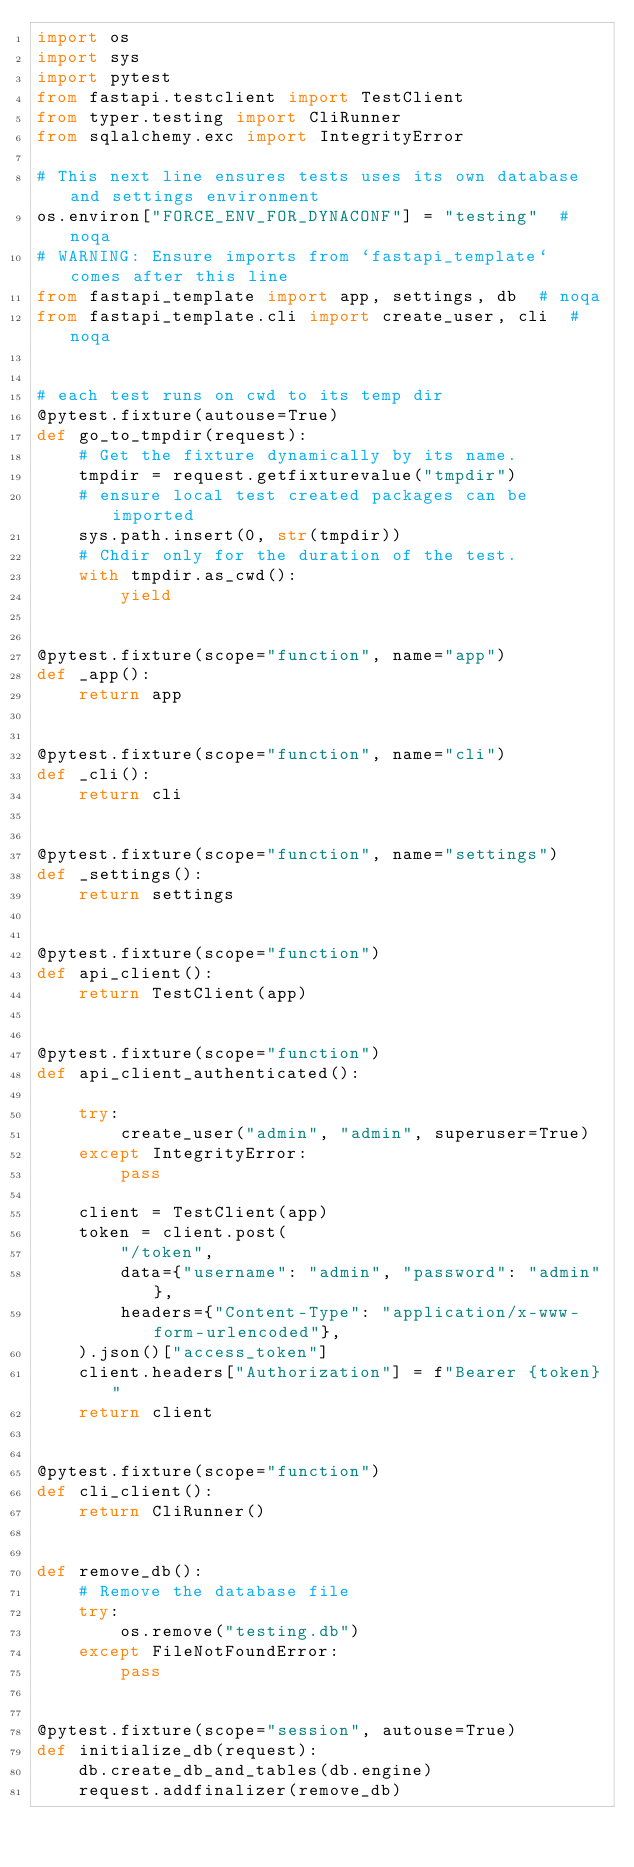Convert code to text. <code><loc_0><loc_0><loc_500><loc_500><_Python_>import os
import sys
import pytest
from fastapi.testclient import TestClient
from typer.testing import CliRunner
from sqlalchemy.exc import IntegrityError

# This next line ensures tests uses its own database and settings environment
os.environ["FORCE_ENV_FOR_DYNACONF"] = "testing"  # noqa
# WARNING: Ensure imports from `fastapi_template` comes after this line
from fastapi_template import app, settings, db  # noqa
from fastapi_template.cli import create_user, cli  # noqa


# each test runs on cwd to its temp dir
@pytest.fixture(autouse=True)
def go_to_tmpdir(request):
    # Get the fixture dynamically by its name.
    tmpdir = request.getfixturevalue("tmpdir")
    # ensure local test created packages can be imported
    sys.path.insert(0, str(tmpdir))
    # Chdir only for the duration of the test.
    with tmpdir.as_cwd():
        yield


@pytest.fixture(scope="function", name="app")
def _app():
    return app


@pytest.fixture(scope="function", name="cli")
def _cli():
    return cli


@pytest.fixture(scope="function", name="settings")
def _settings():
    return settings


@pytest.fixture(scope="function")
def api_client():
    return TestClient(app)


@pytest.fixture(scope="function")
def api_client_authenticated():

    try:
        create_user("admin", "admin", superuser=True)
    except IntegrityError:
        pass

    client = TestClient(app)
    token = client.post(
        "/token",
        data={"username": "admin", "password": "admin"},
        headers={"Content-Type": "application/x-www-form-urlencoded"},
    ).json()["access_token"]
    client.headers["Authorization"] = f"Bearer {token}"
    return client


@pytest.fixture(scope="function")
def cli_client():
    return CliRunner()


def remove_db():
    # Remove the database file
    try:
        os.remove("testing.db")
    except FileNotFoundError:
        pass


@pytest.fixture(scope="session", autouse=True)
def initialize_db(request):
    db.create_db_and_tables(db.engine)
    request.addfinalizer(remove_db)
</code> 